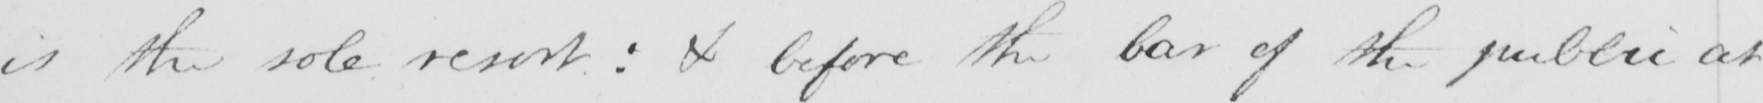Please transcribe the handwritten text in this image. is the sole resort :  & before the bar of the public at 